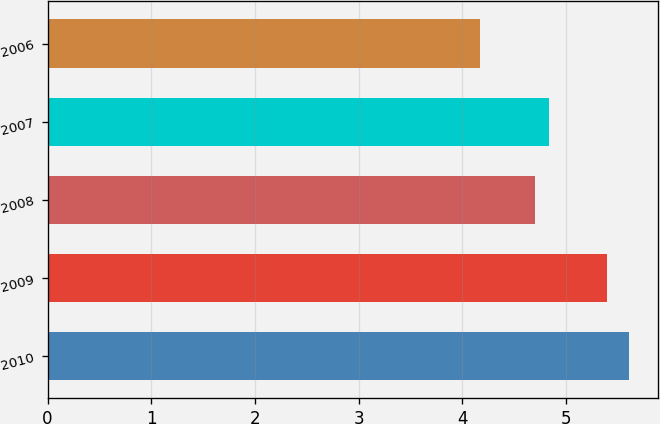Convert chart. <chart><loc_0><loc_0><loc_500><loc_500><bar_chart><fcel>2010<fcel>2009<fcel>2008<fcel>2007<fcel>2006<nl><fcel>5.61<fcel>5.4<fcel>4.7<fcel>4.84<fcel>4.17<nl></chart> 